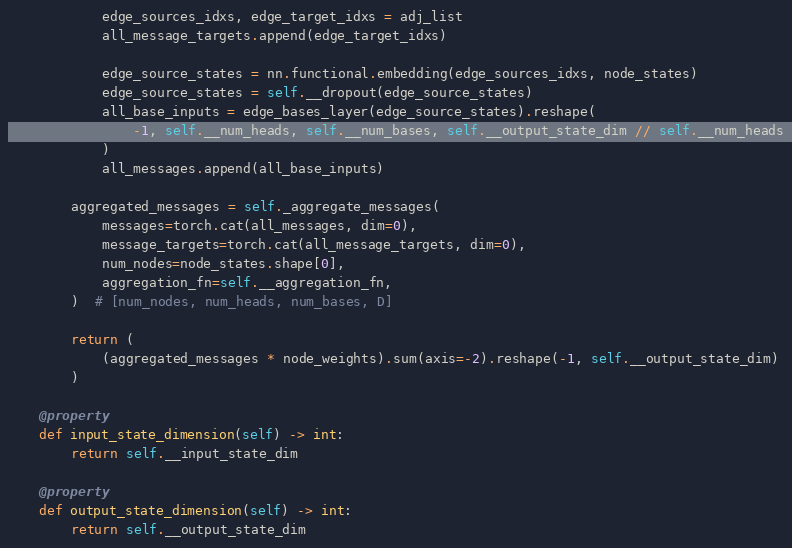Convert code to text. <code><loc_0><loc_0><loc_500><loc_500><_Python_>            edge_sources_idxs, edge_target_idxs = adj_list
            all_message_targets.append(edge_target_idxs)

            edge_source_states = nn.functional.embedding(edge_sources_idxs, node_states)
            edge_source_states = self.__dropout(edge_source_states)
            all_base_inputs = edge_bases_layer(edge_source_states).reshape(
                -1, self.__num_heads, self.__num_bases, self.__output_state_dim // self.__num_heads
            )
            all_messages.append(all_base_inputs)

        aggregated_messages = self._aggregate_messages(
            messages=torch.cat(all_messages, dim=0),
            message_targets=torch.cat(all_message_targets, dim=0),
            num_nodes=node_states.shape[0],
            aggregation_fn=self.__aggregation_fn,
        )  # [num_nodes, num_heads, num_bases, D]

        return (
            (aggregated_messages * node_weights).sum(axis=-2).reshape(-1, self.__output_state_dim)
        )

    @property
    def input_state_dimension(self) -> int:
        return self.__input_state_dim

    @property
    def output_state_dimension(self) -> int:
        return self.__output_state_dim
</code> 